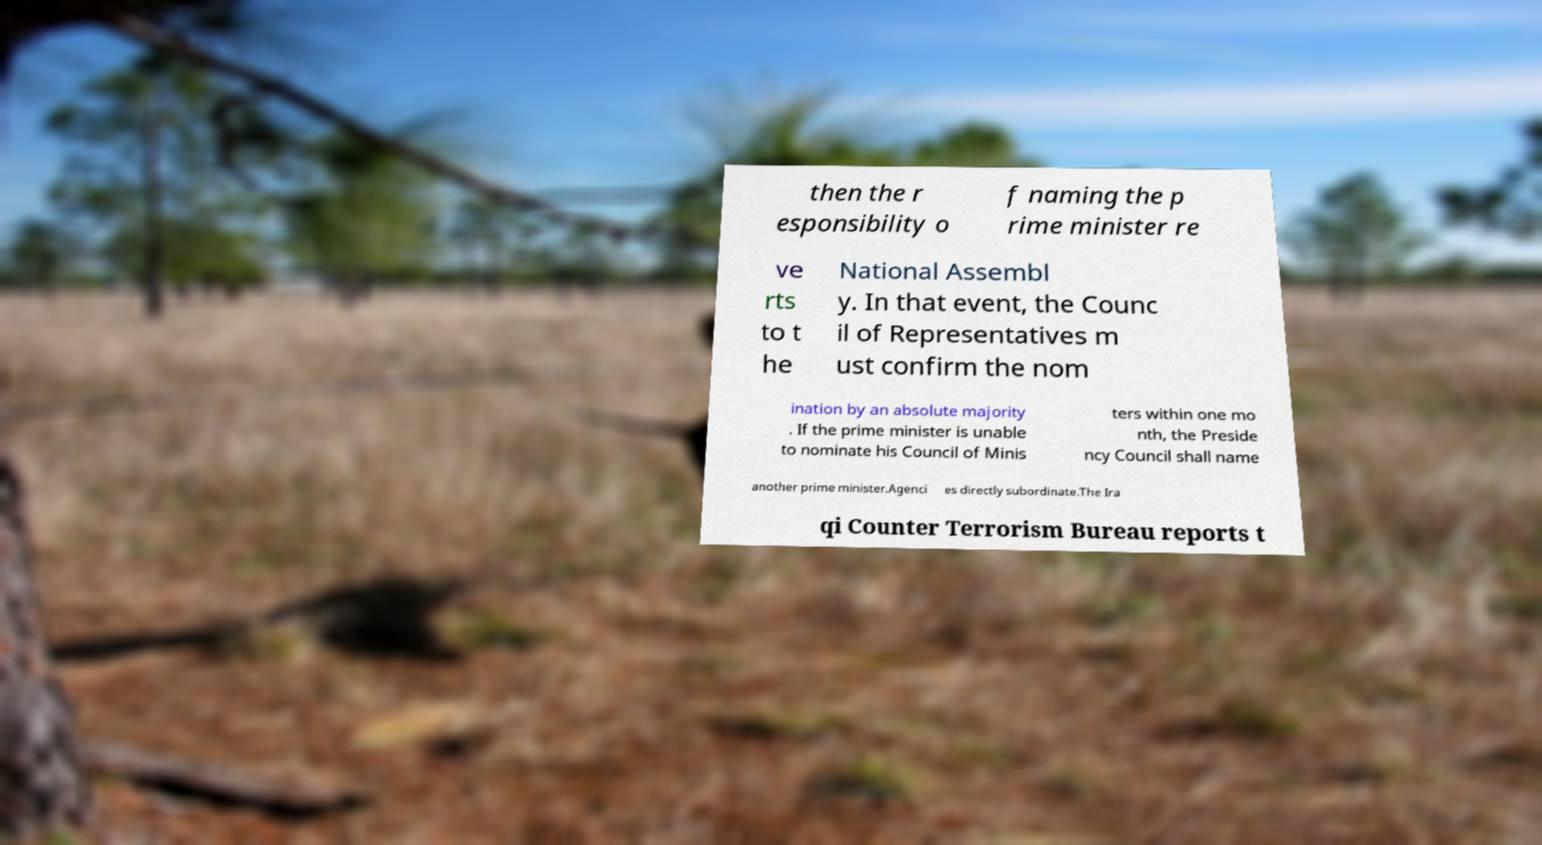Please identify and transcribe the text found in this image. then the r esponsibility o f naming the p rime minister re ve rts to t he National Assembl y. In that event, the Counc il of Representatives m ust confirm the nom ination by an absolute majority . If the prime minister is unable to nominate his Council of Minis ters within one mo nth, the Preside ncy Council shall name another prime minister.Agenci es directly subordinate.The Ira qi Counter Terrorism Bureau reports t 